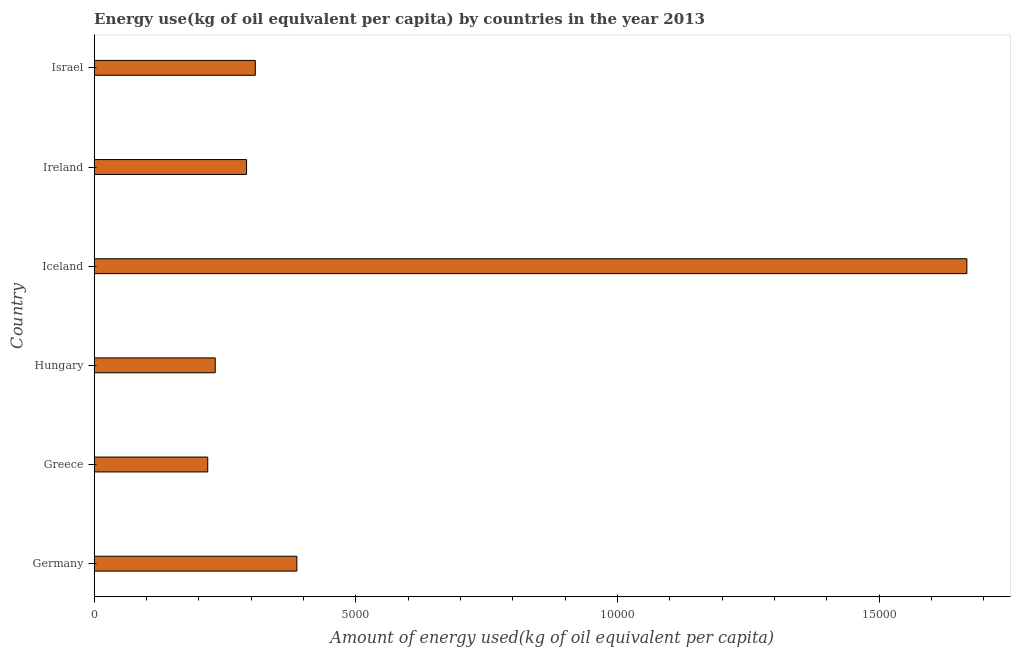What is the title of the graph?
Provide a succinct answer. Energy use(kg of oil equivalent per capita) by countries in the year 2013. What is the label or title of the X-axis?
Make the answer very short. Amount of energy used(kg of oil equivalent per capita). What is the amount of energy used in Israel?
Provide a short and direct response. 3079.38. Across all countries, what is the maximum amount of energy used?
Your answer should be compact. 1.67e+04. Across all countries, what is the minimum amount of energy used?
Provide a succinct answer. 2170.03. What is the sum of the amount of energy used?
Offer a very short reply. 3.10e+04. What is the difference between the amount of energy used in Greece and Iceland?
Offer a terse response. -1.45e+04. What is the average amount of energy used per country?
Provide a short and direct response. 5171.19. What is the median amount of energy used?
Offer a very short reply. 2995.8. What is the ratio of the amount of energy used in Germany to that in Israel?
Make the answer very short. 1.26. What is the difference between the highest and the second highest amount of energy used?
Make the answer very short. 1.28e+04. What is the difference between the highest and the lowest amount of energy used?
Make the answer very short. 1.45e+04. In how many countries, is the amount of energy used greater than the average amount of energy used taken over all countries?
Provide a short and direct response. 1. How many bars are there?
Offer a very short reply. 6. What is the Amount of energy used(kg of oil equivalent per capita) in Germany?
Your answer should be very brief. 3873.63. What is the Amount of energy used(kg of oil equivalent per capita) of Greece?
Provide a short and direct response. 2170.03. What is the Amount of energy used(kg of oil equivalent per capita) in Hungary?
Ensure brevity in your answer.  2312.99. What is the Amount of energy used(kg of oil equivalent per capita) of Iceland?
Offer a terse response. 1.67e+04. What is the Amount of energy used(kg of oil equivalent per capita) in Ireland?
Your response must be concise. 2912.22. What is the Amount of energy used(kg of oil equivalent per capita) in Israel?
Provide a short and direct response. 3079.38. What is the difference between the Amount of energy used(kg of oil equivalent per capita) in Germany and Greece?
Give a very brief answer. 1703.6. What is the difference between the Amount of energy used(kg of oil equivalent per capita) in Germany and Hungary?
Provide a succinct answer. 1560.64. What is the difference between the Amount of energy used(kg of oil equivalent per capita) in Germany and Iceland?
Keep it short and to the point. -1.28e+04. What is the difference between the Amount of energy used(kg of oil equivalent per capita) in Germany and Ireland?
Keep it short and to the point. 961.42. What is the difference between the Amount of energy used(kg of oil equivalent per capita) in Germany and Israel?
Provide a short and direct response. 794.25. What is the difference between the Amount of energy used(kg of oil equivalent per capita) in Greece and Hungary?
Provide a short and direct response. -142.96. What is the difference between the Amount of energy used(kg of oil equivalent per capita) in Greece and Iceland?
Provide a short and direct response. -1.45e+04. What is the difference between the Amount of energy used(kg of oil equivalent per capita) in Greece and Ireland?
Your answer should be very brief. -742.19. What is the difference between the Amount of energy used(kg of oil equivalent per capita) in Greece and Israel?
Provide a succinct answer. -909.35. What is the difference between the Amount of energy used(kg of oil equivalent per capita) in Hungary and Iceland?
Provide a succinct answer. -1.44e+04. What is the difference between the Amount of energy used(kg of oil equivalent per capita) in Hungary and Ireland?
Your response must be concise. -599.22. What is the difference between the Amount of energy used(kg of oil equivalent per capita) in Hungary and Israel?
Offer a very short reply. -766.39. What is the difference between the Amount of energy used(kg of oil equivalent per capita) in Iceland and Ireland?
Offer a terse response. 1.38e+04. What is the difference between the Amount of energy used(kg of oil equivalent per capita) in Iceland and Israel?
Your response must be concise. 1.36e+04. What is the difference between the Amount of energy used(kg of oil equivalent per capita) in Ireland and Israel?
Make the answer very short. -167.17. What is the ratio of the Amount of energy used(kg of oil equivalent per capita) in Germany to that in Greece?
Provide a succinct answer. 1.78. What is the ratio of the Amount of energy used(kg of oil equivalent per capita) in Germany to that in Hungary?
Your response must be concise. 1.68. What is the ratio of the Amount of energy used(kg of oil equivalent per capita) in Germany to that in Iceland?
Make the answer very short. 0.23. What is the ratio of the Amount of energy used(kg of oil equivalent per capita) in Germany to that in Ireland?
Ensure brevity in your answer.  1.33. What is the ratio of the Amount of energy used(kg of oil equivalent per capita) in Germany to that in Israel?
Provide a short and direct response. 1.26. What is the ratio of the Amount of energy used(kg of oil equivalent per capita) in Greece to that in Hungary?
Offer a very short reply. 0.94. What is the ratio of the Amount of energy used(kg of oil equivalent per capita) in Greece to that in Iceland?
Your answer should be compact. 0.13. What is the ratio of the Amount of energy used(kg of oil equivalent per capita) in Greece to that in Ireland?
Offer a terse response. 0.74. What is the ratio of the Amount of energy used(kg of oil equivalent per capita) in Greece to that in Israel?
Your answer should be very brief. 0.7. What is the ratio of the Amount of energy used(kg of oil equivalent per capita) in Hungary to that in Iceland?
Your response must be concise. 0.14. What is the ratio of the Amount of energy used(kg of oil equivalent per capita) in Hungary to that in Ireland?
Keep it short and to the point. 0.79. What is the ratio of the Amount of energy used(kg of oil equivalent per capita) in Hungary to that in Israel?
Provide a short and direct response. 0.75. What is the ratio of the Amount of energy used(kg of oil equivalent per capita) in Iceland to that in Ireland?
Provide a short and direct response. 5.73. What is the ratio of the Amount of energy used(kg of oil equivalent per capita) in Iceland to that in Israel?
Your response must be concise. 5.42. What is the ratio of the Amount of energy used(kg of oil equivalent per capita) in Ireland to that in Israel?
Offer a very short reply. 0.95. 